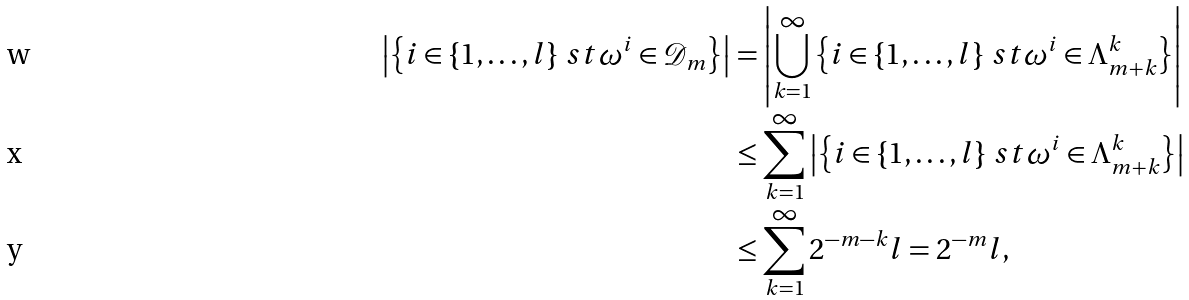<formula> <loc_0><loc_0><loc_500><loc_500>\left | \left \{ i \in \{ 1 , \dots , l \} \ s t \omega ^ { i } \in \mathcal { D } _ { m } \right \} \right | & = \left | \bigcup _ { k = 1 } ^ { \infty } \left \{ i \in \{ 1 , \dots , l \} \ s t \omega ^ { i } \in \Lambda ^ { k } _ { m + k } \right \} \right | \\ & \leq \sum _ { k = 1 } ^ { \infty } \left | \left \{ i \in \{ 1 , \dots , l \} \ s t \omega ^ { i } \in \Lambda ^ { k } _ { m + k } \right \} \right | \\ & \leq \sum _ { k = 1 } ^ { \infty } 2 ^ { - m - k } l = 2 ^ { - m } l ,</formula> 